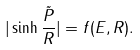Convert formula to latex. <formula><loc_0><loc_0><loc_500><loc_500>| \sinh { \frac { \tilde { P } } { R } } | = f ( E , R ) .</formula> 